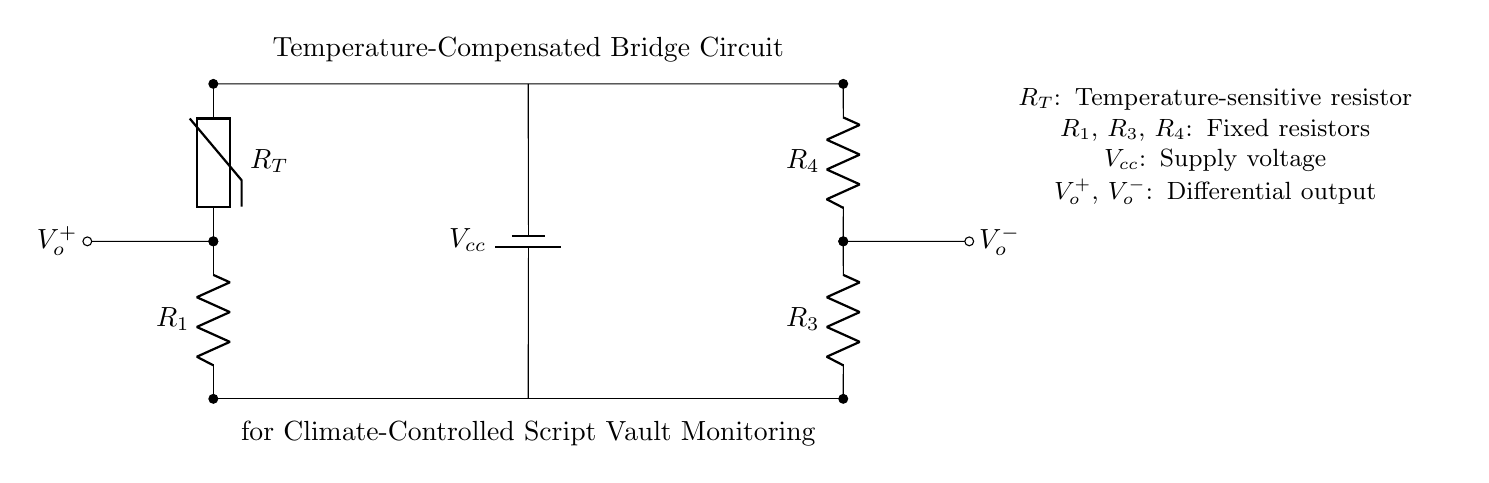What type of circuit is shown? The circuit is a bridge circuit, characterized by its specific arrangement of resistive components to measure a differential voltage across its output.
Answer: bridge circuit What component is temperature-sensitive? The thermistor is responsible for sensing temperature, changing its resistance with temperature variations.
Answer: thermistor What are the values of the fixed resistors in this circuit? The circuit includes three fixed resistors, specifically $R_1$, $R_3$, and $R_4$, which are not assigned particular values in the diagram as they depend on design choices.
Answer: $R_1$, $R_3$, $R_4$ What is the purpose of the voltage source? The voltage source, indicated as $V_{cc}$, supplies the bridge circuit with the necessary potential difference to function and enable voltage measurement between the points.
Answer: supply voltage What does the output voltage indicate? The output voltage $V_o^+$ and $V_o^-$ represent the differential voltage between the two junctions of the bridge circuit, which can indicate changes in temperature due to the varying resistance of the thermistor.
Answer: differential output How does the thermistor affect the bridge balance? As the temperature changes, the resistance of the thermistor varies, resulting in a change in the balance of the bridge circuit and, consequently, a change in the output voltage.
Answer: changes output voltage What is the significance of the circuit's design for environmental monitoring? The design allows precise measurement of temperature fluctuations, ensuring that the climate-controlled script vault maintains optimal conditions for script preservation.
Answer: precise temperature measurement 